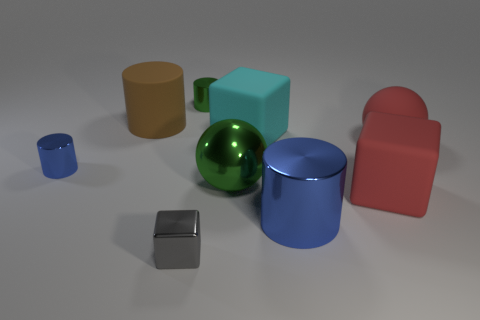Do the large sphere that is left of the large red ball and the large red cube have the same material?
Ensure brevity in your answer.  No. How many metallic balls are there?
Keep it short and to the point. 1. How many objects are either large red matte blocks or metal cylinders?
Give a very brief answer. 4. What number of metal objects are in front of the metallic cylinder behind the big ball on the right side of the large metal cylinder?
Ensure brevity in your answer.  4. Is there anything else that has the same color as the large matte cylinder?
Your response must be concise. No. Do the shiny object that is right of the big green metal object and the metallic thing that is left of the small gray metal block have the same color?
Your answer should be compact. Yes. Is the number of big green things that are on the right side of the small green metal object greater than the number of big cyan things in front of the big rubber ball?
Provide a succinct answer. Yes. What material is the large green object?
Keep it short and to the point. Metal. What is the shape of the blue metal object that is to the left of the metal cylinder that is in front of the small cylinder that is in front of the brown rubber thing?
Offer a very short reply. Cylinder. How many other things are the same material as the green cylinder?
Provide a short and direct response. 4. 